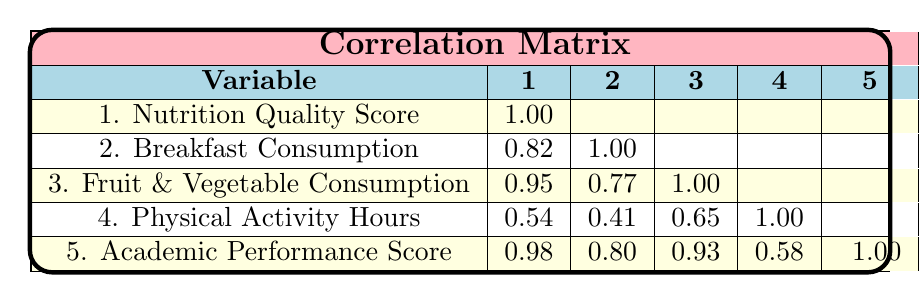What is the correlation between Nutrition Quality Score and Academic Performance Score? The correlation coefficient between Nutrition Quality Score and Academic Performance Score is 0.98, indicating a very strong positive relationship.
Answer: 0.98 Is there a correlation between Breakfast Consumption and Fruit & Vegetable Consumption? The correlation coefficient between Breakfast Consumption and Fruit & Vegetable Consumption is 0.77, which shows a moderate positive correlation.
Answer: 0.77 What is the average Nutrition Quality Score of the children? The Nutrition Quality Scores are 85, 75, 90, 70, 65, 80. Adding these gives 465, and dividing by the number of children (6) gives an average of 77.5.
Answer: 77.5 Does higher Physical Activity Hours correlate with better Academic Performance Score? The correlation coefficient between Physical Activity Hours and Academic Performance Score is 0.58, indicating a weak to moderate positive correlation suggesting that more physical activity is somewhat related to better academic performance.
Answer: Yes Which variable has the highest correlation with Academic Performance Score? The highest correlation with Academic Performance Score is from Nutrition Quality Score with a correlation coefficient of 0.98, indicating that it is the most strongly related variable.
Answer: Nutrition Quality Score What is the difference between the maximum and minimum Academic Performance Scores? The maximum Academic Performance Score is 95 and the minimum is 65. The difference is 95 - 65 = 30.
Answer: 30 Does increased Fruit & Vegetable Consumption correlate with higher Academic Performance? Yes, the correlation coefficient between Fruit & Vegetable Consumption and Academic Performance Score is 0.93, indicating a strong positive correlation.
Answer: Yes What is the correlation between Physical Activity Hours and Nutrition Quality Score? The correlation coefficient between Physical Activity Hours and Nutrition Quality Score is 0.54, which indicates a moderate positive correlation, suggesting that as nutrition quality increases, physical activity hours also tend to increase.
Answer: 0.54 What average score of Academic Performance do children with Breakfast Consumption have? The Academic Performance scores for children who consumed breakfast are 90, 80, 95, and 85. Their sum is 350, and dividing by the number of children (4), the average score is 87.5.
Answer: 87.5 